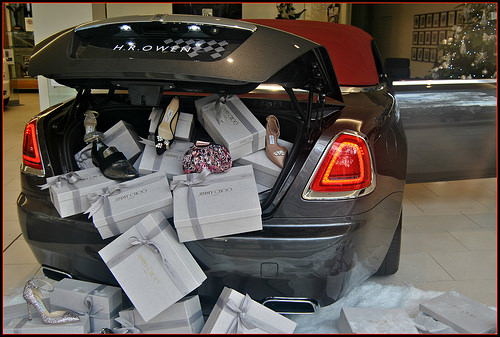<image>
Can you confirm if the shoe is on the box? No. The shoe is not positioned on the box. They may be near each other, but the shoe is not supported by or resting on top of the box. 